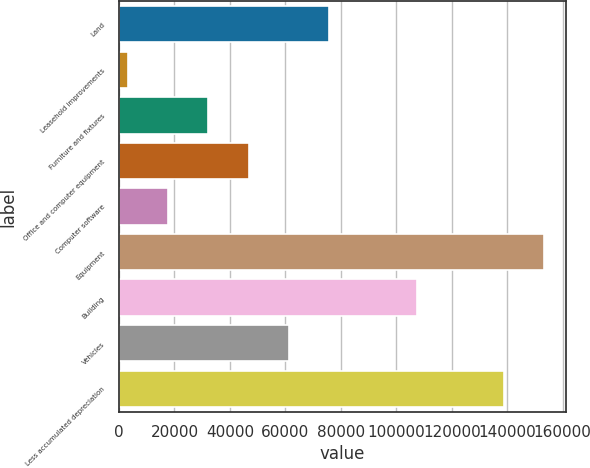Convert chart. <chart><loc_0><loc_0><loc_500><loc_500><bar_chart><fcel>Land<fcel>Leasehold improvements<fcel>Furniture and fixtures<fcel>Office and computer equipment<fcel>Computer software<fcel>Equipment<fcel>Building<fcel>Vehicles<fcel>Less accumulated depreciation<nl><fcel>75771.5<fcel>3109<fcel>32174<fcel>46706.5<fcel>17641.5<fcel>153342<fcel>107374<fcel>61239<fcel>138810<nl></chart> 